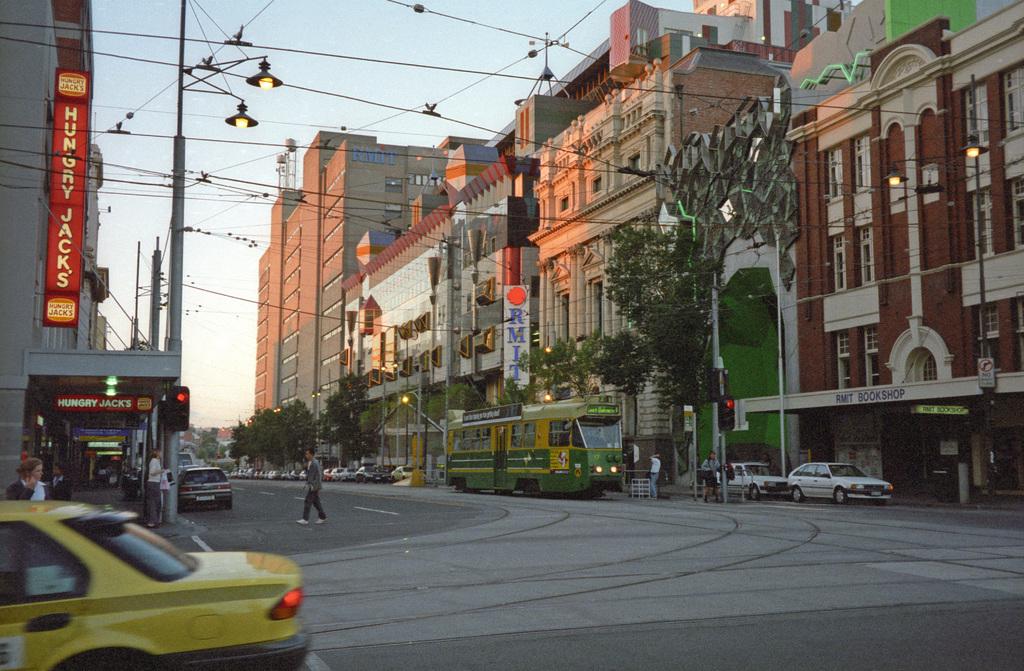What is wrote on the left in white and red?
Keep it short and to the point. Hungry jack's. 